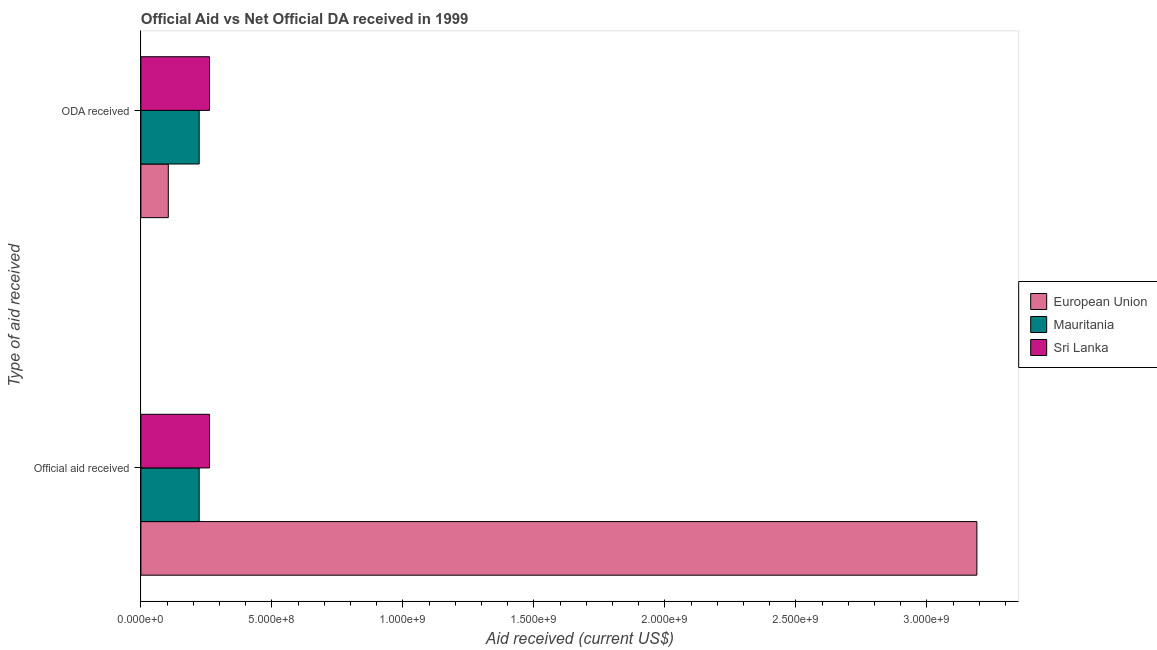How many different coloured bars are there?
Provide a succinct answer. 3. How many groups of bars are there?
Offer a terse response. 2. Are the number of bars on each tick of the Y-axis equal?
Provide a succinct answer. Yes. What is the label of the 2nd group of bars from the top?
Your response must be concise. Official aid received. What is the official aid received in Mauritania?
Provide a short and direct response. 2.22e+08. Across all countries, what is the maximum oda received?
Provide a short and direct response. 2.62e+08. Across all countries, what is the minimum official aid received?
Your answer should be compact. 2.22e+08. In which country was the oda received maximum?
Give a very brief answer. Sri Lanka. In which country was the official aid received minimum?
Provide a succinct answer. Mauritania. What is the total official aid received in the graph?
Give a very brief answer. 3.67e+09. What is the difference between the official aid received in Sri Lanka and that in Mauritania?
Give a very brief answer. 3.95e+07. What is the difference between the oda received in European Union and the official aid received in Sri Lanka?
Provide a short and direct response. -1.57e+08. What is the average oda received per country?
Offer a very short reply. 1.96e+08. What is the difference between the official aid received and oda received in Sri Lanka?
Offer a very short reply. 0. In how many countries, is the official aid received greater than 3200000000 US$?
Your answer should be very brief. 0. What is the ratio of the official aid received in European Union to that in Mauritania?
Give a very brief answer. 14.34. What does the 1st bar from the top in ODA received represents?
Your response must be concise. Sri Lanka. What does the 1st bar from the bottom in ODA received represents?
Offer a terse response. European Union. How many bars are there?
Ensure brevity in your answer.  6. Are all the bars in the graph horizontal?
Your answer should be very brief. Yes. What is the difference between two consecutive major ticks on the X-axis?
Give a very brief answer. 5.00e+08. Are the values on the major ticks of X-axis written in scientific E-notation?
Keep it short and to the point. Yes. Does the graph contain any zero values?
Keep it short and to the point. No. Does the graph contain grids?
Make the answer very short. No. Where does the legend appear in the graph?
Provide a short and direct response. Center right. How many legend labels are there?
Give a very brief answer. 3. How are the legend labels stacked?
Provide a short and direct response. Vertical. What is the title of the graph?
Provide a succinct answer. Official Aid vs Net Official DA received in 1999 . What is the label or title of the X-axis?
Your answer should be very brief. Aid received (current US$). What is the label or title of the Y-axis?
Keep it short and to the point. Type of aid received. What is the Aid received (current US$) in European Union in Official aid received?
Offer a terse response. 3.19e+09. What is the Aid received (current US$) in Mauritania in Official aid received?
Your answer should be very brief. 2.22e+08. What is the Aid received (current US$) of Sri Lanka in Official aid received?
Your answer should be very brief. 2.62e+08. What is the Aid received (current US$) in European Union in ODA received?
Your answer should be very brief. 1.05e+08. What is the Aid received (current US$) in Mauritania in ODA received?
Offer a very short reply. 2.22e+08. What is the Aid received (current US$) in Sri Lanka in ODA received?
Your answer should be compact. 2.62e+08. Across all Type of aid received, what is the maximum Aid received (current US$) of European Union?
Provide a succinct answer. 3.19e+09. Across all Type of aid received, what is the maximum Aid received (current US$) in Mauritania?
Your answer should be very brief. 2.22e+08. Across all Type of aid received, what is the maximum Aid received (current US$) of Sri Lanka?
Your answer should be compact. 2.62e+08. Across all Type of aid received, what is the minimum Aid received (current US$) of European Union?
Ensure brevity in your answer.  1.05e+08. Across all Type of aid received, what is the minimum Aid received (current US$) in Mauritania?
Your answer should be compact. 2.22e+08. Across all Type of aid received, what is the minimum Aid received (current US$) in Sri Lanka?
Offer a terse response. 2.62e+08. What is the total Aid received (current US$) of European Union in the graph?
Your answer should be compact. 3.30e+09. What is the total Aid received (current US$) of Mauritania in the graph?
Your response must be concise. 4.45e+08. What is the total Aid received (current US$) of Sri Lanka in the graph?
Your answer should be compact. 5.24e+08. What is the difference between the Aid received (current US$) of European Union in Official aid received and that in ODA received?
Your answer should be very brief. 3.09e+09. What is the difference between the Aid received (current US$) in European Union in Official aid received and the Aid received (current US$) in Mauritania in ODA received?
Provide a succinct answer. 2.97e+09. What is the difference between the Aid received (current US$) of European Union in Official aid received and the Aid received (current US$) of Sri Lanka in ODA received?
Your answer should be very brief. 2.93e+09. What is the difference between the Aid received (current US$) in Mauritania in Official aid received and the Aid received (current US$) in Sri Lanka in ODA received?
Provide a short and direct response. -3.95e+07. What is the average Aid received (current US$) of European Union per Type of aid received?
Provide a short and direct response. 1.65e+09. What is the average Aid received (current US$) of Mauritania per Type of aid received?
Give a very brief answer. 2.22e+08. What is the average Aid received (current US$) of Sri Lanka per Type of aid received?
Make the answer very short. 2.62e+08. What is the difference between the Aid received (current US$) in European Union and Aid received (current US$) in Mauritania in Official aid received?
Provide a short and direct response. 2.97e+09. What is the difference between the Aid received (current US$) of European Union and Aid received (current US$) of Sri Lanka in Official aid received?
Your answer should be very brief. 2.93e+09. What is the difference between the Aid received (current US$) in Mauritania and Aid received (current US$) in Sri Lanka in Official aid received?
Provide a short and direct response. -3.95e+07. What is the difference between the Aid received (current US$) of European Union and Aid received (current US$) of Mauritania in ODA received?
Offer a very short reply. -1.18e+08. What is the difference between the Aid received (current US$) of European Union and Aid received (current US$) of Sri Lanka in ODA received?
Provide a succinct answer. -1.57e+08. What is the difference between the Aid received (current US$) of Mauritania and Aid received (current US$) of Sri Lanka in ODA received?
Provide a succinct answer. -3.95e+07. What is the ratio of the Aid received (current US$) of European Union in Official aid received to that in ODA received?
Ensure brevity in your answer.  30.5. What is the ratio of the Aid received (current US$) of Mauritania in Official aid received to that in ODA received?
Keep it short and to the point. 1. What is the difference between the highest and the second highest Aid received (current US$) of European Union?
Offer a very short reply. 3.09e+09. What is the difference between the highest and the second highest Aid received (current US$) in Mauritania?
Offer a very short reply. 0. What is the difference between the highest and the lowest Aid received (current US$) in European Union?
Your answer should be very brief. 3.09e+09. What is the difference between the highest and the lowest Aid received (current US$) in Mauritania?
Ensure brevity in your answer.  0. What is the difference between the highest and the lowest Aid received (current US$) of Sri Lanka?
Provide a succinct answer. 0. 